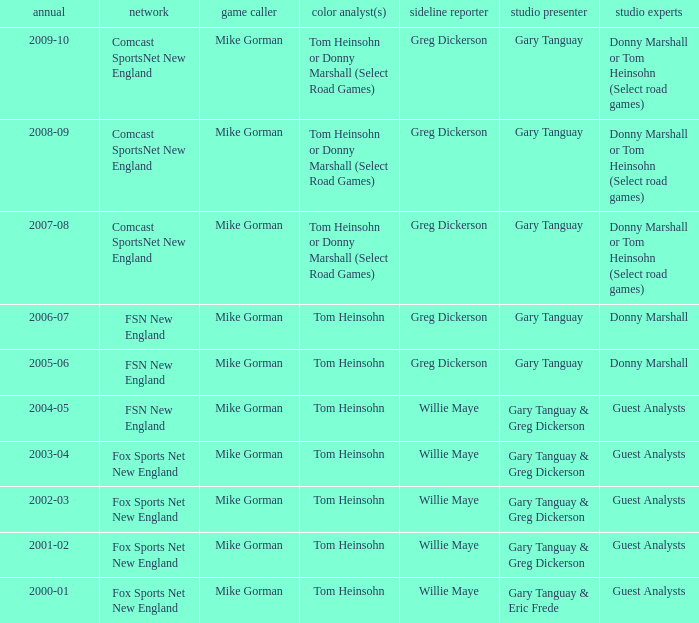WHich Play-by-play has a Studio host of gary tanguay, and a Studio analysts of donny marshall? Mike Gorman, Mike Gorman. 